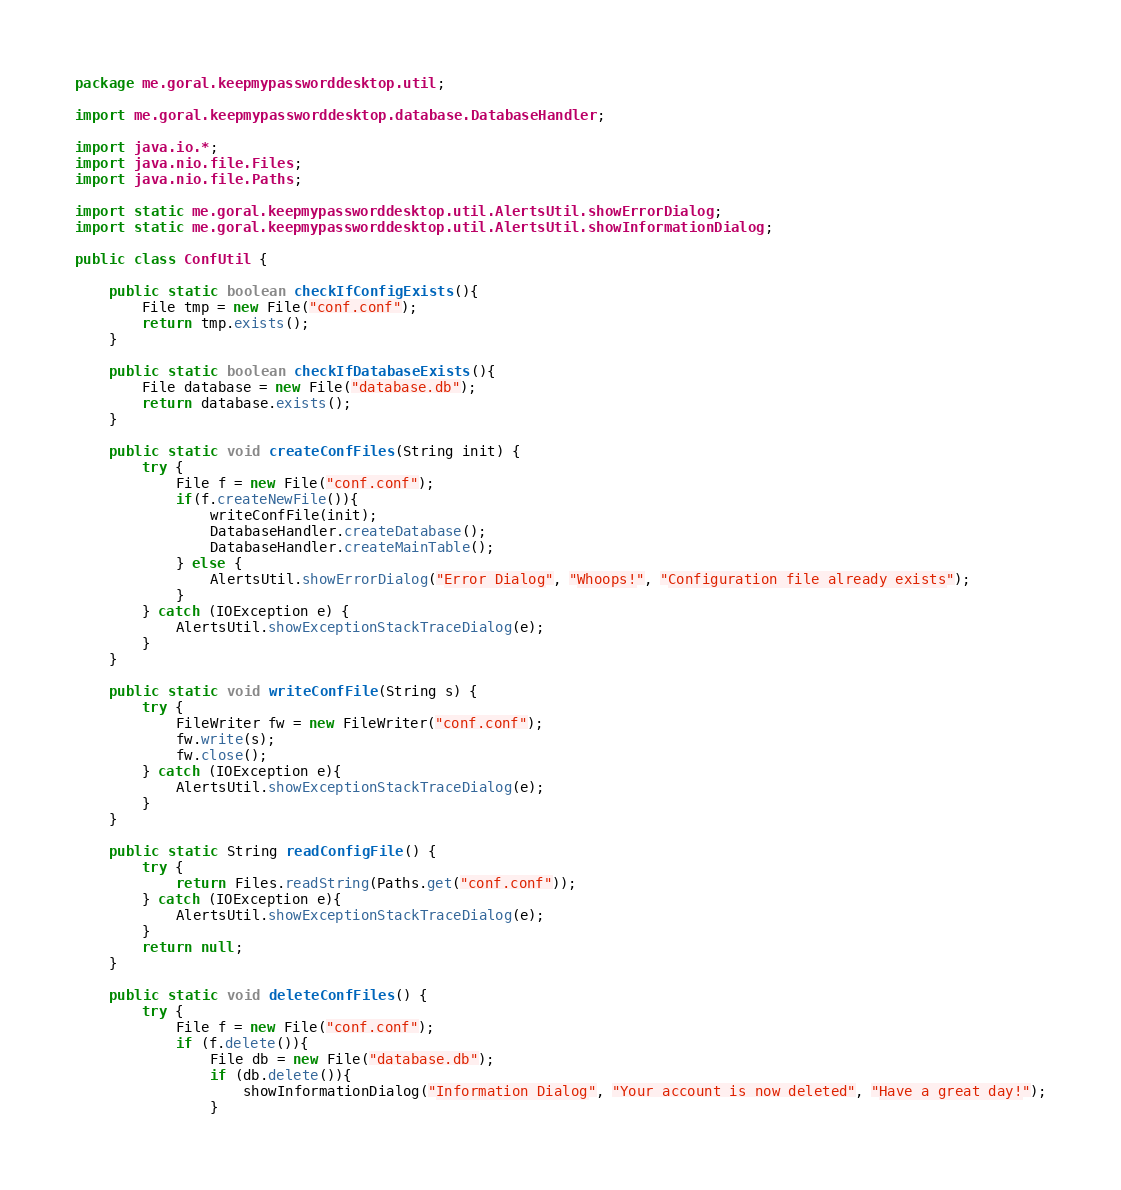<code> <loc_0><loc_0><loc_500><loc_500><_Java_>package me.goral.keepmypassworddesktop.util;

import me.goral.keepmypassworddesktop.database.DatabaseHandler;

import java.io.*;
import java.nio.file.Files;
import java.nio.file.Paths;

import static me.goral.keepmypassworddesktop.util.AlertsUtil.showErrorDialog;
import static me.goral.keepmypassworddesktop.util.AlertsUtil.showInformationDialog;

public class ConfUtil {

    public static boolean checkIfConfigExists(){
        File tmp = new File("conf.conf");
        return tmp.exists();
    }

    public static boolean checkIfDatabaseExists(){
        File database = new File("database.db");
        return database.exists();
    }

    public static void createConfFiles(String init) {
        try {
            File f = new File("conf.conf");
            if(f.createNewFile()){
                writeConfFile(init);
                DatabaseHandler.createDatabase();
                DatabaseHandler.createMainTable();
            } else {
                AlertsUtil.showErrorDialog("Error Dialog", "Whoops!", "Configuration file already exists");
            }
        } catch (IOException e) {
            AlertsUtil.showExceptionStackTraceDialog(e);
        }
    }

    public static void writeConfFile(String s) {
        try {
            FileWriter fw = new FileWriter("conf.conf");
            fw.write(s);
            fw.close();
        } catch (IOException e){
            AlertsUtil.showExceptionStackTraceDialog(e);
        }
    }

    public static String readConfigFile() {
        try {
            return Files.readString(Paths.get("conf.conf"));
        } catch (IOException e){
            AlertsUtil.showExceptionStackTraceDialog(e);
        }
        return null;
    }

    public static void deleteConfFiles() {
        try {
            File f = new File("conf.conf");
            if (f.delete()){
                File db = new File("database.db");
                if (db.delete()){
                    showInformationDialog("Information Dialog", "Your account is now deleted", "Have a great day!");
                }</code> 